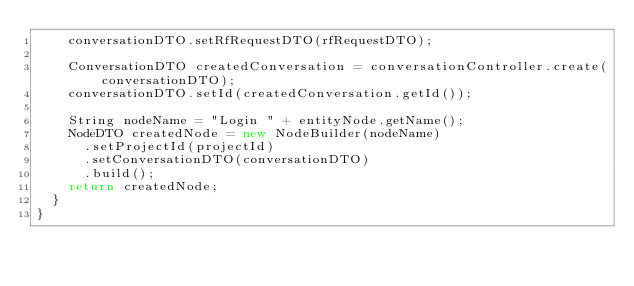<code> <loc_0><loc_0><loc_500><loc_500><_Java_>    conversationDTO.setRfRequestDTO(rfRequestDTO);

    ConversationDTO createdConversation = conversationController.create(conversationDTO);
    conversationDTO.setId(createdConversation.getId());

    String nodeName = "Login " + entityNode.getName();
    NodeDTO createdNode = new NodeBuilder(nodeName)
      .setProjectId(projectId)
      .setConversationDTO(conversationDTO)
      .build();
    return createdNode;
  }
}</code> 